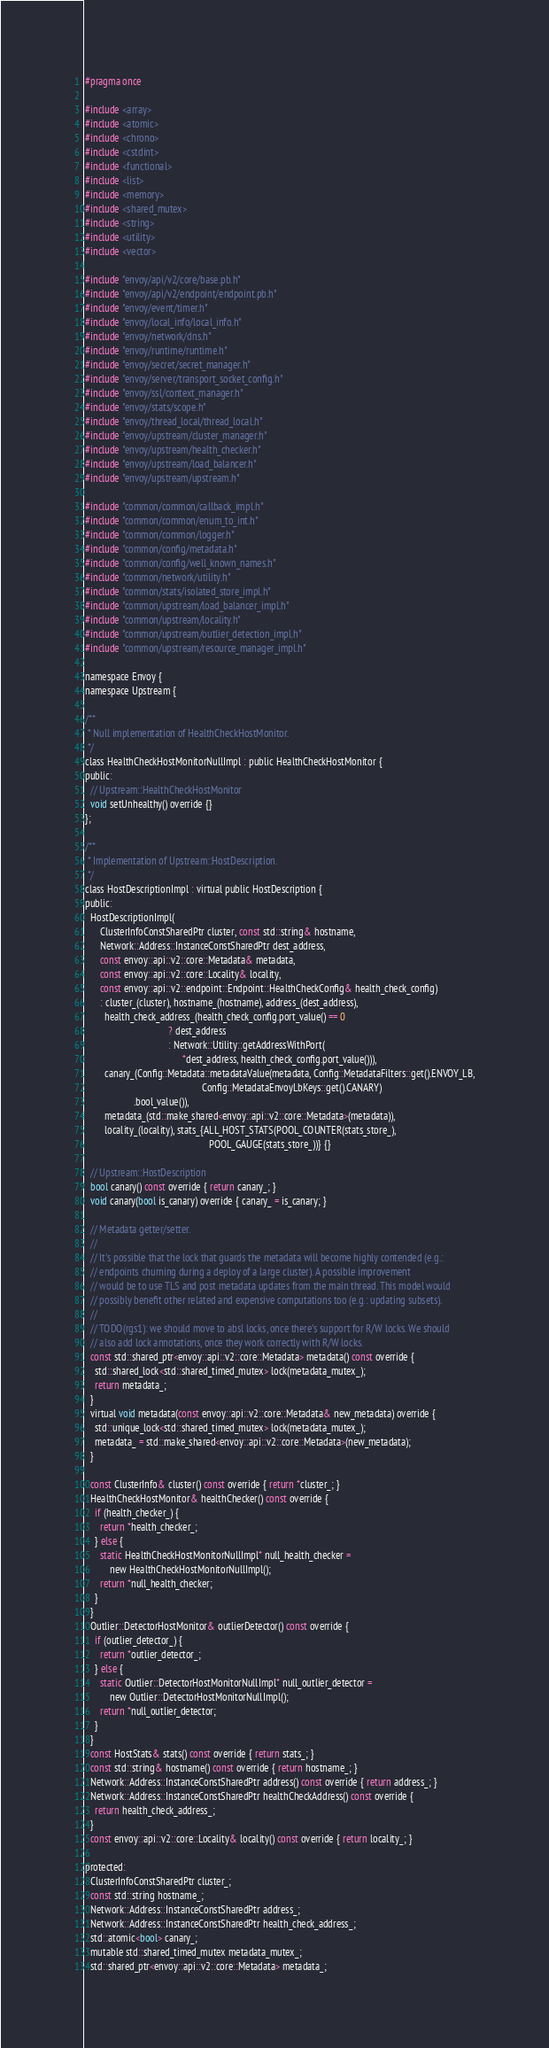<code> <loc_0><loc_0><loc_500><loc_500><_C_>#pragma once

#include <array>
#include <atomic>
#include <chrono>
#include <cstdint>
#include <functional>
#include <list>
#include <memory>
#include <shared_mutex>
#include <string>
#include <utility>
#include <vector>

#include "envoy/api/v2/core/base.pb.h"
#include "envoy/api/v2/endpoint/endpoint.pb.h"
#include "envoy/event/timer.h"
#include "envoy/local_info/local_info.h"
#include "envoy/network/dns.h"
#include "envoy/runtime/runtime.h"
#include "envoy/secret/secret_manager.h"
#include "envoy/server/transport_socket_config.h"
#include "envoy/ssl/context_manager.h"
#include "envoy/stats/scope.h"
#include "envoy/thread_local/thread_local.h"
#include "envoy/upstream/cluster_manager.h"
#include "envoy/upstream/health_checker.h"
#include "envoy/upstream/load_balancer.h"
#include "envoy/upstream/upstream.h"

#include "common/common/callback_impl.h"
#include "common/common/enum_to_int.h"
#include "common/common/logger.h"
#include "common/config/metadata.h"
#include "common/config/well_known_names.h"
#include "common/network/utility.h"
#include "common/stats/isolated_store_impl.h"
#include "common/upstream/load_balancer_impl.h"
#include "common/upstream/locality.h"
#include "common/upstream/outlier_detection_impl.h"
#include "common/upstream/resource_manager_impl.h"

namespace Envoy {
namespace Upstream {

/**
 * Null implementation of HealthCheckHostMonitor.
 */
class HealthCheckHostMonitorNullImpl : public HealthCheckHostMonitor {
public:
  // Upstream::HealthCheckHostMonitor
  void setUnhealthy() override {}
};

/**
 * Implementation of Upstream::HostDescription.
 */
class HostDescriptionImpl : virtual public HostDescription {
public:
  HostDescriptionImpl(
      ClusterInfoConstSharedPtr cluster, const std::string& hostname,
      Network::Address::InstanceConstSharedPtr dest_address,
      const envoy::api::v2::core::Metadata& metadata,
      const envoy::api::v2::core::Locality& locality,
      const envoy::api::v2::endpoint::Endpoint::HealthCheckConfig& health_check_config)
      : cluster_(cluster), hostname_(hostname), address_(dest_address),
        health_check_address_(health_check_config.port_value() == 0
                                  ? dest_address
                                  : Network::Utility::getAddressWithPort(
                                        *dest_address, health_check_config.port_value())),
        canary_(Config::Metadata::metadataValue(metadata, Config::MetadataFilters::get().ENVOY_LB,
                                                Config::MetadataEnvoyLbKeys::get().CANARY)
                    .bool_value()),
        metadata_(std::make_shared<envoy::api::v2::core::Metadata>(metadata)),
        locality_(locality), stats_{ALL_HOST_STATS(POOL_COUNTER(stats_store_),
                                                   POOL_GAUGE(stats_store_))} {}

  // Upstream::HostDescription
  bool canary() const override { return canary_; }
  void canary(bool is_canary) override { canary_ = is_canary; }

  // Metadata getter/setter.
  //
  // It's possible that the lock that guards the metadata will become highly contended (e.g.:
  // endpoints churning during a deploy of a large cluster). A possible improvement
  // would be to use TLS and post metadata updates from the main thread. This model would
  // possibly benefit other related and expensive computations too (e.g.: updating subsets).
  //
  // TODO(rgs1): we should move to absl locks, once there's support for R/W locks. We should
  // also add lock annotations, once they work correctly with R/W locks.
  const std::shared_ptr<envoy::api::v2::core::Metadata> metadata() const override {
    std::shared_lock<std::shared_timed_mutex> lock(metadata_mutex_);
    return metadata_;
  }
  virtual void metadata(const envoy::api::v2::core::Metadata& new_metadata) override {
    std::unique_lock<std::shared_timed_mutex> lock(metadata_mutex_);
    metadata_ = std::make_shared<envoy::api::v2::core::Metadata>(new_metadata);
  }

  const ClusterInfo& cluster() const override { return *cluster_; }
  HealthCheckHostMonitor& healthChecker() const override {
    if (health_checker_) {
      return *health_checker_;
    } else {
      static HealthCheckHostMonitorNullImpl* null_health_checker =
          new HealthCheckHostMonitorNullImpl();
      return *null_health_checker;
    }
  }
  Outlier::DetectorHostMonitor& outlierDetector() const override {
    if (outlier_detector_) {
      return *outlier_detector_;
    } else {
      static Outlier::DetectorHostMonitorNullImpl* null_outlier_detector =
          new Outlier::DetectorHostMonitorNullImpl();
      return *null_outlier_detector;
    }
  }
  const HostStats& stats() const override { return stats_; }
  const std::string& hostname() const override { return hostname_; }
  Network::Address::InstanceConstSharedPtr address() const override { return address_; }
  Network::Address::InstanceConstSharedPtr healthCheckAddress() const override {
    return health_check_address_;
  }
  const envoy::api::v2::core::Locality& locality() const override { return locality_; }

protected:
  ClusterInfoConstSharedPtr cluster_;
  const std::string hostname_;
  Network::Address::InstanceConstSharedPtr address_;
  Network::Address::InstanceConstSharedPtr health_check_address_;
  std::atomic<bool> canary_;
  mutable std::shared_timed_mutex metadata_mutex_;
  std::shared_ptr<envoy::api::v2::core::Metadata> metadata_;</code> 